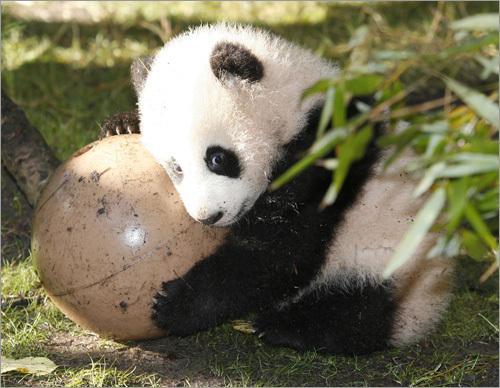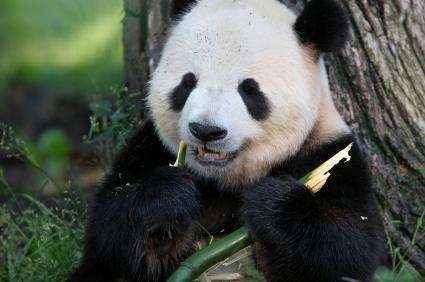The first image is the image on the left, the second image is the image on the right. Given the left and right images, does the statement "A panda is eating bamboo." hold true? Answer yes or no. Yes. The first image is the image on the left, the second image is the image on the right. Considering the images on both sides, is "Panda in the right image is nibbling something." valid? Answer yes or no. Yes. The first image is the image on the left, the second image is the image on the right. For the images shown, is this caption "One image shows a panda at play." true? Answer yes or no. Yes. The first image is the image on the left, the second image is the image on the right. Given the left and right images, does the statement "An image shows a panda munching on a branch." hold true? Answer yes or no. Yes. 